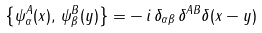<formula> <loc_0><loc_0><loc_500><loc_500>\left \{ \psi _ { \alpha } ^ { A } ( x ) , \, \psi _ { \beta } ^ { B } ( y ) \right \} = - \, i \, \delta _ { \alpha \beta } \, \delta ^ { A B } \delta ( x - y )</formula> 